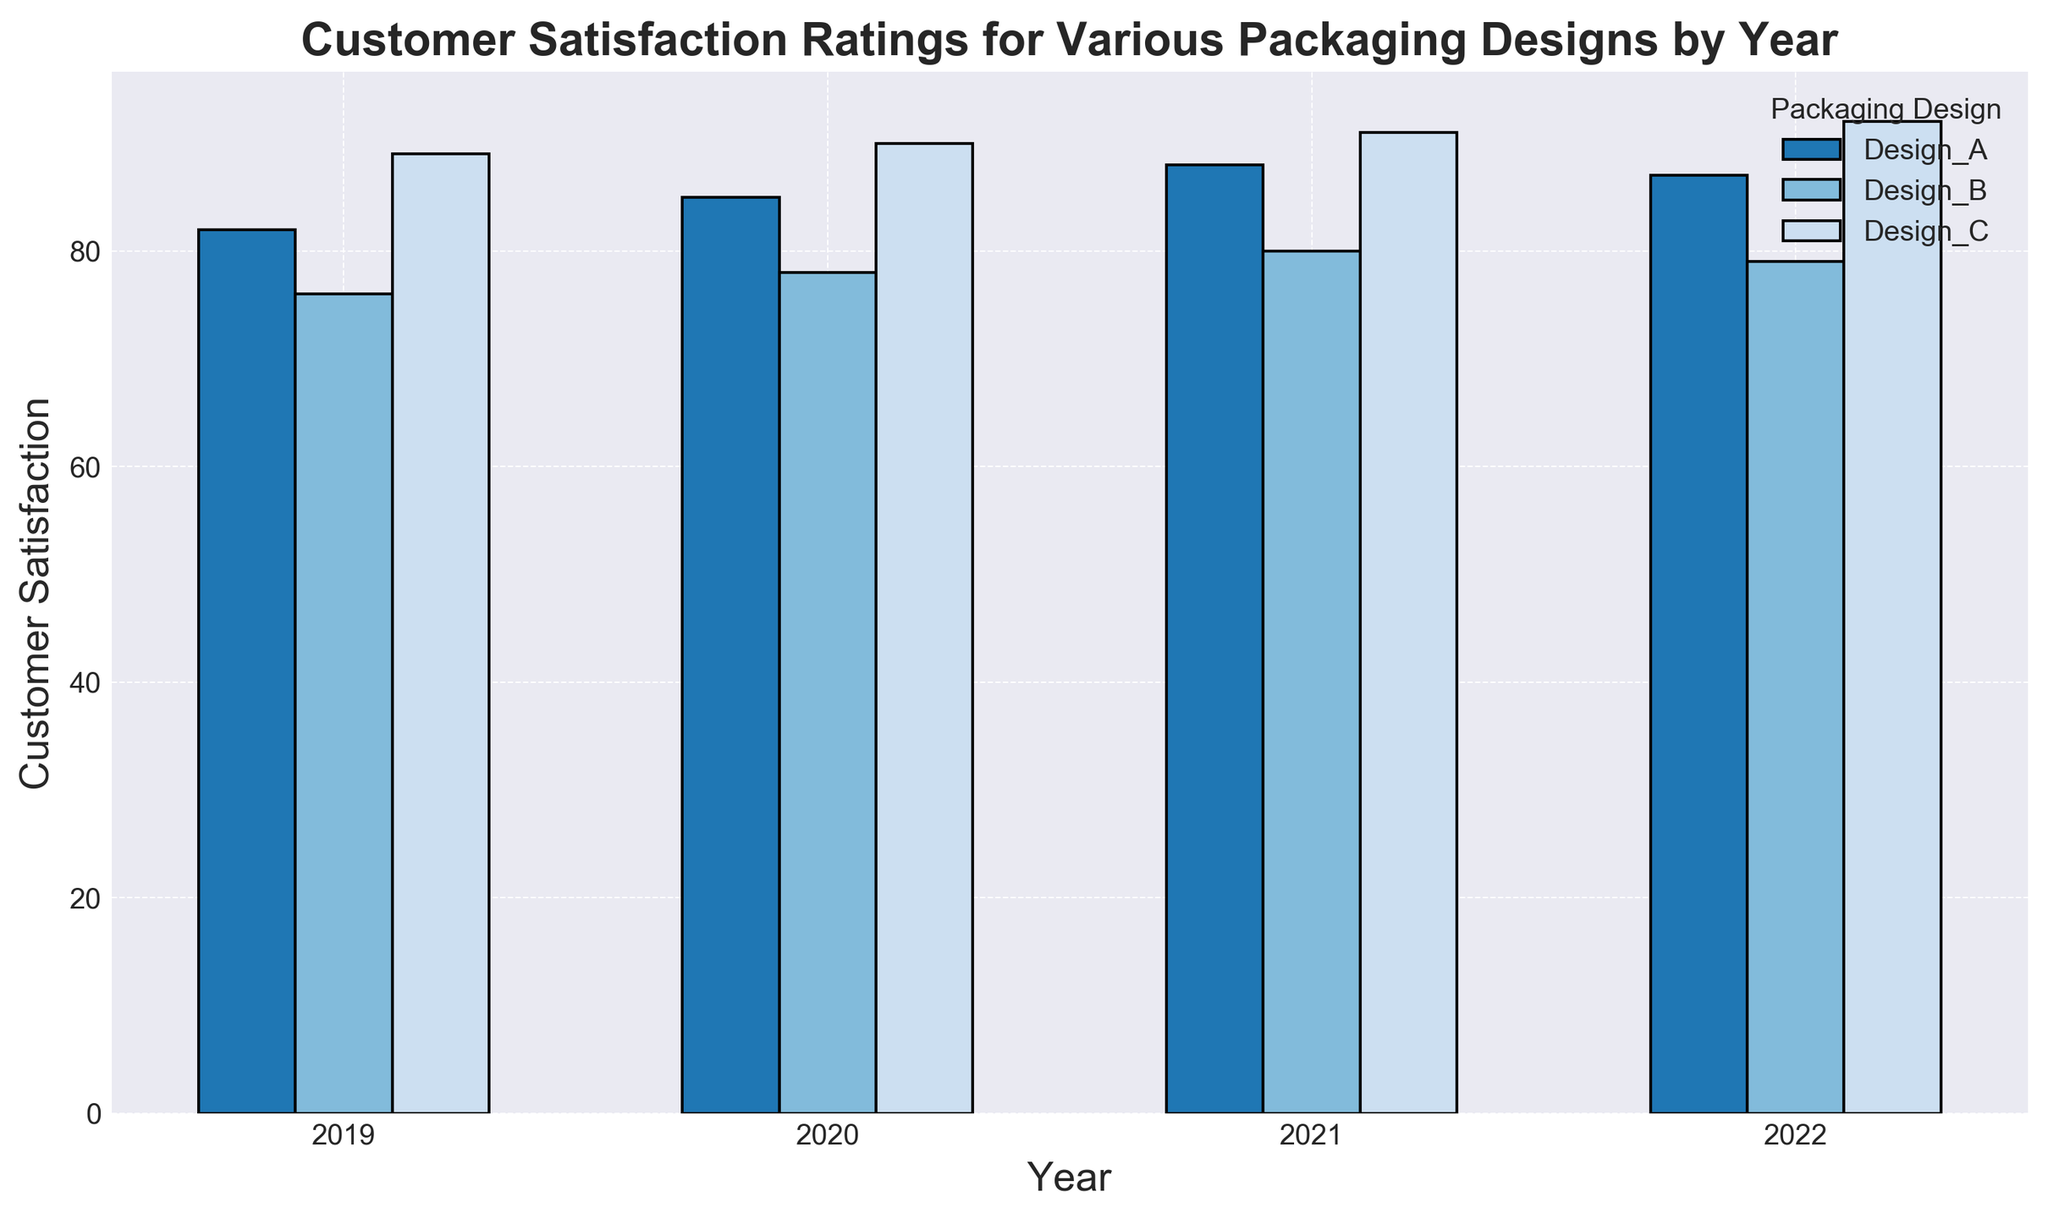What is the highest customer satisfaction rating for Design_A in any year? To find the highest rating for Design_A, look at the bar heights for Design_A across all the years. The highest point is in 2021 with a satisfaction score of 88.
Answer: 88 Which packaging design had the lowest customer satisfaction in 2022? To determine the lowest rating in 2022, compare the bar heights for all designs in that year. Design_B has the lowest bar with a satisfaction score of 79.
Answer: Design_B How has the customer satisfaction rating for Design_B changed from 2019 to 2022? Look at the bar heights for Design_B in 2019 and 2022. The rating was 76 in 2019 and increased to 79 in 2022, showing a slight increase.
Answer: Increased by 3 points What is the average customer satisfaction rating for Design_C over the four years? Add the satisfaction scores for Design_C over the years: 89 (2019), 90 (2020), 91 (2021), and 92 (2022). The total is 362. Divide this by 4 (the number of years): 362 / 4 = 90.5.
Answer: 90.5 Which year saw the highest overall customer satisfaction for packaging designs? Identify the year where the sum of the satisfaction scores for all designs is highest. For simplicity, one can visually estimate that 2022 has high bars for all designs. By summing: 87 (Design_A) + 79 (Design_B) + 92 (Design_C) = 258, which is the highest overall score.
Answer: 2022 In which year was the difference between the highest and lowest customer satisfaction ratings the smallest? Look for the year with the smallest range between the highest and lowest bars. For 2022, the highest is 92 (Design_C) and the lowest is 79 (Design_B), giving a difference of 13. No other year has a smaller difference.
Answer: 2022 Which design has shown a consistent increase in customer satisfaction rating every year? Compare the bar heights for each design across the years. Design_A and Design_C show consistent increases.
Answer: Design_A and Design_C What is the combined customer satisfaction rating for all designs in 2020? Sum the satisfaction scores for all designs in 2020: 85 (Design_A) + 78 (Design_B) + 90 (Design_C) = 253.
Answer: 253 By how much did the customer satisfaction rating for Design_A improve from 2019 to 2021? Compare the ratings for Design_A in 2019 and 2021: 88 (2021) - 82 (2019) = 6.
Answer: 6 points 